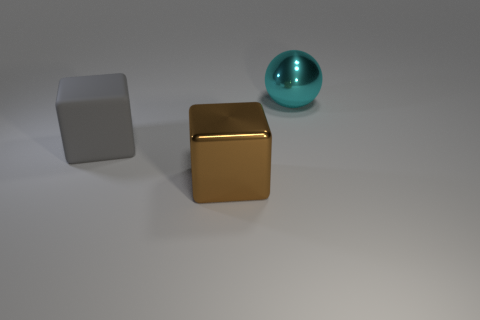Add 1 big metal blocks. How many objects exist? 4 Subtract all balls. How many objects are left? 2 Add 2 large cyan spheres. How many large cyan spheres exist? 3 Subtract 0 blue cubes. How many objects are left? 3 Subtract all big gray metal things. Subtract all large things. How many objects are left? 0 Add 3 large things. How many large things are left? 6 